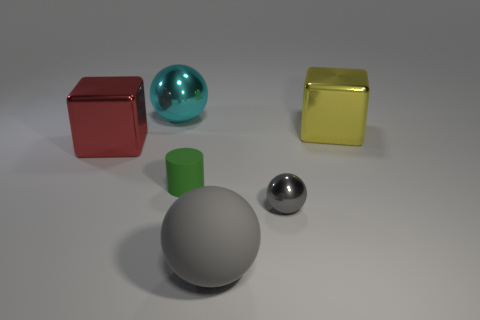How many other objects are the same shape as the big cyan thing?
Your answer should be very brief. 2. What is the color of the big object in front of the big metallic block left of the small shiny thing that is to the right of the large gray object?
Offer a very short reply. Gray. How many red shiny things are there?
Offer a very short reply. 1. What number of tiny objects are gray matte things or yellow objects?
Give a very brief answer. 0. What is the shape of the gray thing that is the same size as the cyan metal ball?
Make the answer very short. Sphere. Are there any other things that are the same size as the red object?
Your answer should be compact. Yes. What is the large thing left of the big ball behind the small gray metallic ball made of?
Offer a very short reply. Metal. Is the green object the same size as the rubber sphere?
Provide a short and direct response. No. What number of things are either shiny balls that are left of the tiny gray ball or gray shiny blocks?
Keep it short and to the point. 1. The large thing that is behind the big shiny thing that is to the right of the small gray object is what shape?
Offer a very short reply. Sphere. 